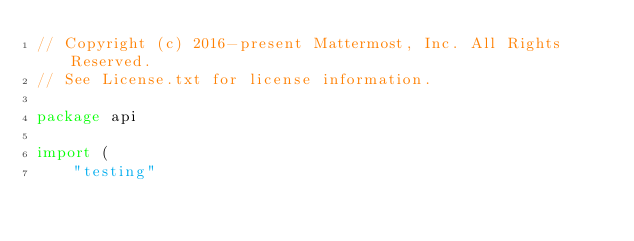<code> <loc_0><loc_0><loc_500><loc_500><_Go_>// Copyright (c) 2016-present Mattermost, Inc. All Rights Reserved.
// See License.txt for license information.

package api

import (
	"testing"</code> 